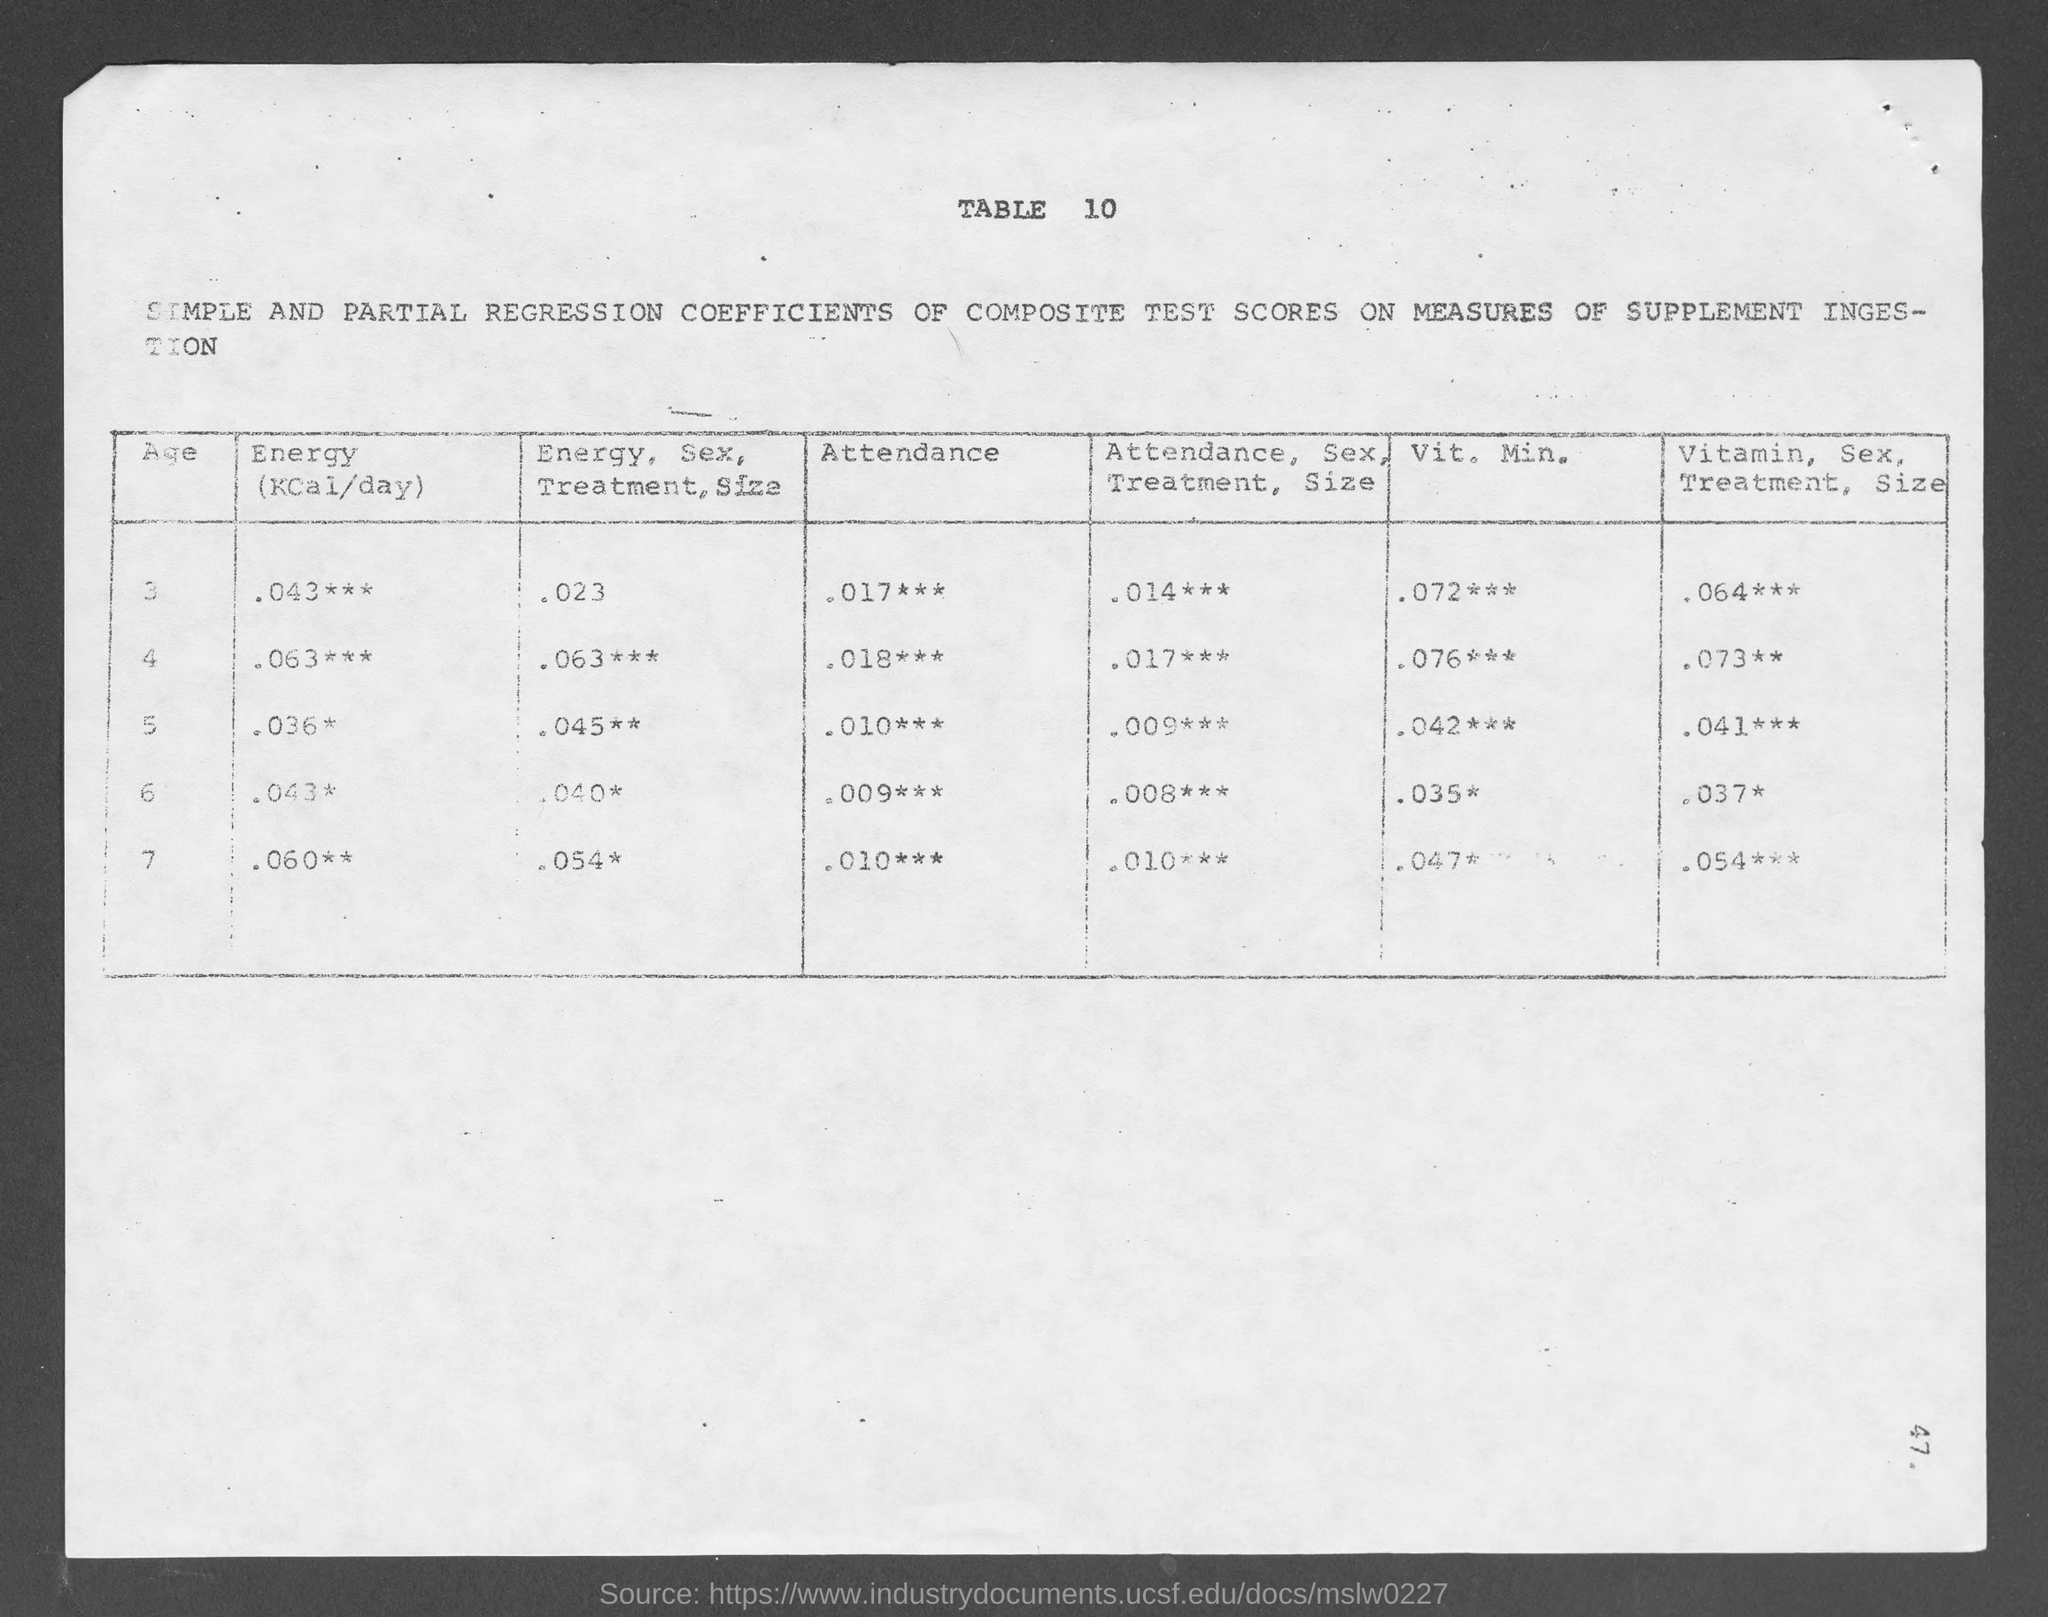Can you explain the significance of the asterisks in the table? The asterisks in the table likely denote the level of statistical significance of the results shown. Generally, one asterisk might indicate a significance level of 0.05, two asterisks for 0.01, and three asterisks for 0.001. This signifies how likely it is that the observed results are due to chance rather than the factors being measured. 